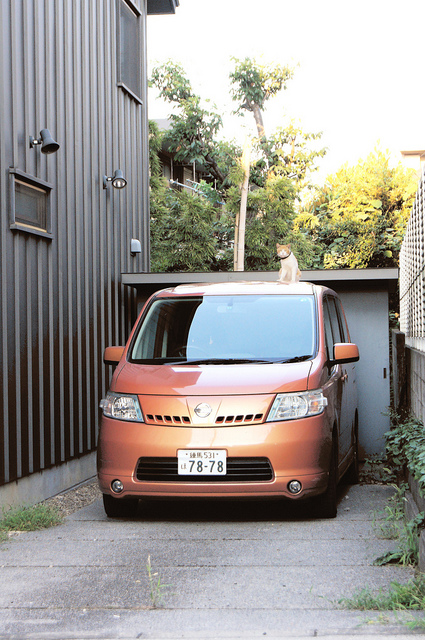Identify the text contained in this image. 78 78 